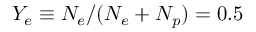Convert formula to latex. <formula><loc_0><loc_0><loc_500><loc_500>Y _ { e } \equiv N _ { e } / ( N _ { e } + N _ { p } ) = 0 . 5</formula> 